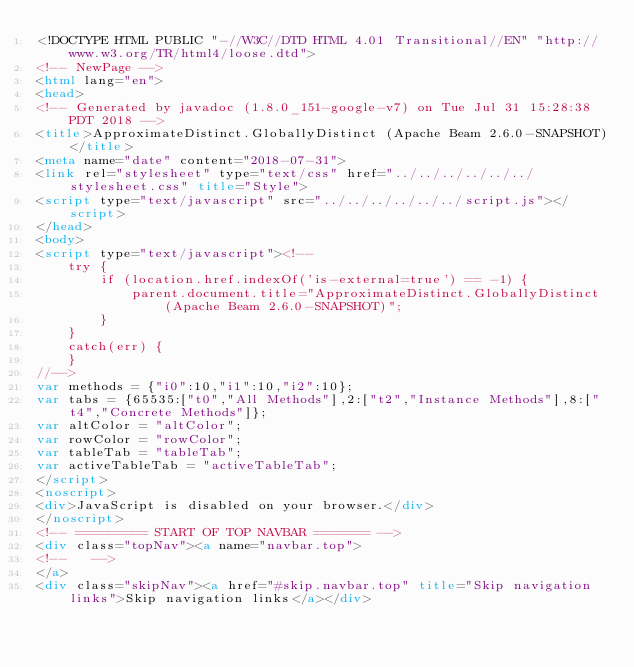Convert code to text. <code><loc_0><loc_0><loc_500><loc_500><_HTML_><!DOCTYPE HTML PUBLIC "-//W3C//DTD HTML 4.01 Transitional//EN" "http://www.w3.org/TR/html4/loose.dtd">
<!-- NewPage -->
<html lang="en">
<head>
<!-- Generated by javadoc (1.8.0_151-google-v7) on Tue Jul 31 15:28:38 PDT 2018 -->
<title>ApproximateDistinct.GloballyDistinct (Apache Beam 2.6.0-SNAPSHOT)</title>
<meta name="date" content="2018-07-31">
<link rel="stylesheet" type="text/css" href="../../../../../../stylesheet.css" title="Style">
<script type="text/javascript" src="../../../../../../script.js"></script>
</head>
<body>
<script type="text/javascript"><!--
    try {
        if (location.href.indexOf('is-external=true') == -1) {
            parent.document.title="ApproximateDistinct.GloballyDistinct (Apache Beam 2.6.0-SNAPSHOT)";
        }
    }
    catch(err) {
    }
//-->
var methods = {"i0":10,"i1":10,"i2":10};
var tabs = {65535:["t0","All Methods"],2:["t2","Instance Methods"],8:["t4","Concrete Methods"]};
var altColor = "altColor";
var rowColor = "rowColor";
var tableTab = "tableTab";
var activeTableTab = "activeTableTab";
</script>
<noscript>
<div>JavaScript is disabled on your browser.</div>
</noscript>
<!-- ========= START OF TOP NAVBAR ======= -->
<div class="topNav"><a name="navbar.top">
<!--   -->
</a>
<div class="skipNav"><a href="#skip.navbar.top" title="Skip navigation links">Skip navigation links</a></div></code> 